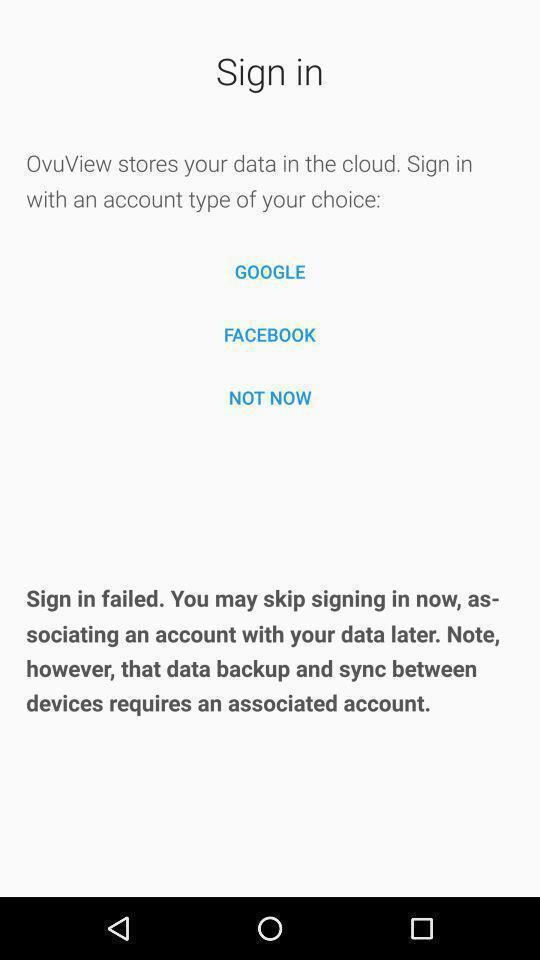What can you discern from this picture? Sign-in page of ovuview tracks monthly cycle. 